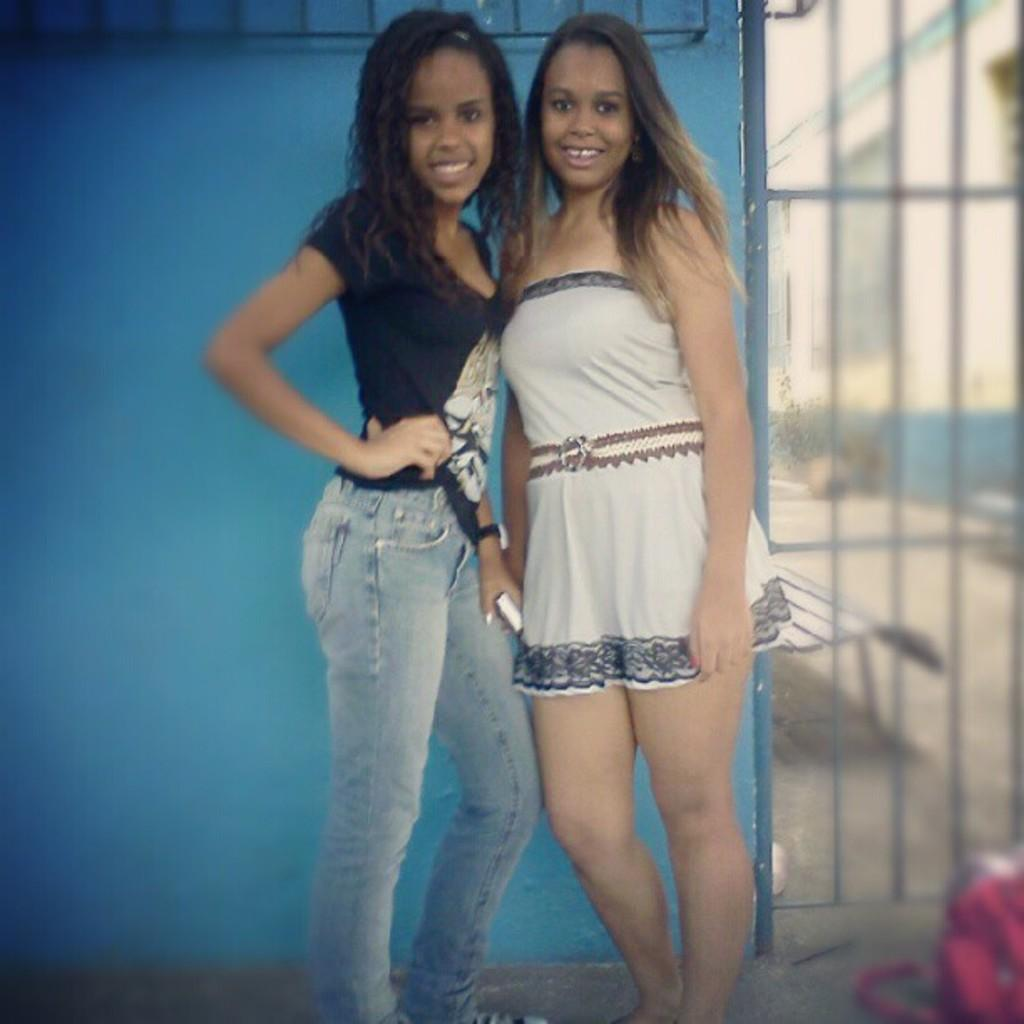How many people are in the image? There are two girls in the image. What are the girls doing in the image? The girls are posing for a photograph. What color is the wall in the background of the image? The wall in the background of the image is blue. Which side of the image is blurred? The left side of the image is blurred. What is the cause of the argument between the girls in the image? There is no argument between the girls in the image; they are posing for a photograph. What type of pleasure can be seen on the girls' faces in the image? There is no indication of pleasure on the girls' faces in the image, as they are posing for a photograph. 